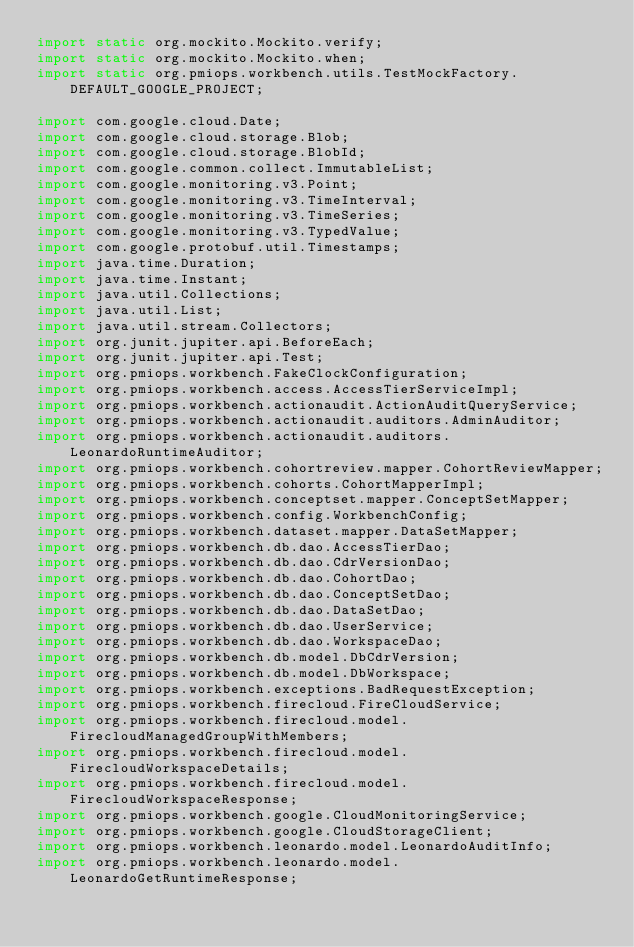Convert code to text. <code><loc_0><loc_0><loc_500><loc_500><_Java_>import static org.mockito.Mockito.verify;
import static org.mockito.Mockito.when;
import static org.pmiops.workbench.utils.TestMockFactory.DEFAULT_GOOGLE_PROJECT;

import com.google.cloud.Date;
import com.google.cloud.storage.Blob;
import com.google.cloud.storage.BlobId;
import com.google.common.collect.ImmutableList;
import com.google.monitoring.v3.Point;
import com.google.monitoring.v3.TimeInterval;
import com.google.monitoring.v3.TimeSeries;
import com.google.monitoring.v3.TypedValue;
import com.google.protobuf.util.Timestamps;
import java.time.Duration;
import java.time.Instant;
import java.util.Collections;
import java.util.List;
import java.util.stream.Collectors;
import org.junit.jupiter.api.BeforeEach;
import org.junit.jupiter.api.Test;
import org.pmiops.workbench.FakeClockConfiguration;
import org.pmiops.workbench.access.AccessTierServiceImpl;
import org.pmiops.workbench.actionaudit.ActionAuditQueryService;
import org.pmiops.workbench.actionaudit.auditors.AdminAuditor;
import org.pmiops.workbench.actionaudit.auditors.LeonardoRuntimeAuditor;
import org.pmiops.workbench.cohortreview.mapper.CohortReviewMapper;
import org.pmiops.workbench.cohorts.CohortMapperImpl;
import org.pmiops.workbench.conceptset.mapper.ConceptSetMapper;
import org.pmiops.workbench.config.WorkbenchConfig;
import org.pmiops.workbench.dataset.mapper.DataSetMapper;
import org.pmiops.workbench.db.dao.AccessTierDao;
import org.pmiops.workbench.db.dao.CdrVersionDao;
import org.pmiops.workbench.db.dao.CohortDao;
import org.pmiops.workbench.db.dao.ConceptSetDao;
import org.pmiops.workbench.db.dao.DataSetDao;
import org.pmiops.workbench.db.dao.UserService;
import org.pmiops.workbench.db.dao.WorkspaceDao;
import org.pmiops.workbench.db.model.DbCdrVersion;
import org.pmiops.workbench.db.model.DbWorkspace;
import org.pmiops.workbench.exceptions.BadRequestException;
import org.pmiops.workbench.firecloud.FireCloudService;
import org.pmiops.workbench.firecloud.model.FirecloudManagedGroupWithMembers;
import org.pmiops.workbench.firecloud.model.FirecloudWorkspaceDetails;
import org.pmiops.workbench.firecloud.model.FirecloudWorkspaceResponse;
import org.pmiops.workbench.google.CloudMonitoringService;
import org.pmiops.workbench.google.CloudStorageClient;
import org.pmiops.workbench.leonardo.model.LeonardoAuditInfo;
import org.pmiops.workbench.leonardo.model.LeonardoGetRuntimeResponse;</code> 